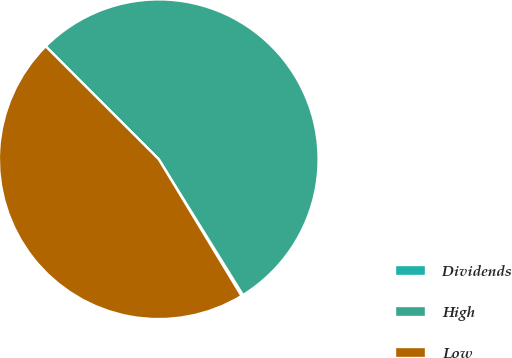Convert chart. <chart><loc_0><loc_0><loc_500><loc_500><pie_chart><fcel>Dividends<fcel>High<fcel>Low<nl><fcel>0.17%<fcel>53.68%<fcel>46.16%<nl></chart> 